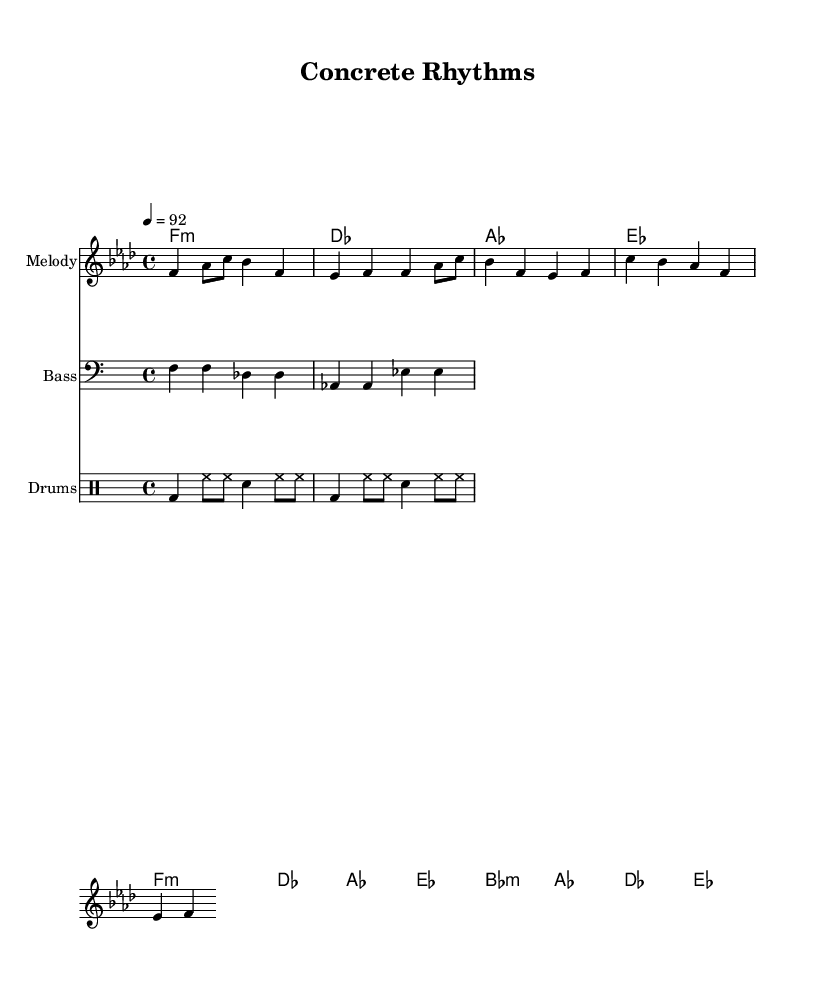What is the key signature of this music? The key signature is indicated by the number of flats or sharps at the beginning of the staff. Here, the music is in F minor, which has four flats (B, E, A, and D).
Answer: F minor What is the time signature of the music sheet? The time signature is displayed as a fraction at the beginning of the staff. In this case, it shows 4/4, indicating four beats per measure and a quarter note receives one beat.
Answer: 4/4 What is the tempo marking for this piece? The tempo is noted at the beginning with a specific numeric value. This piece is marked at 92 beats per minute, indicating how fast it should be played.
Answer: 92 How many measures are in the melody section? By counting the vertical lines (bar lines) in the melody part, we can determine the number of measures. There are eight measures in total in the melody section.
Answer: Eight What is the first chord in the harmony section? The first chord is indicated at the beginning of the harmony line and is notated with the chord name. The first chord here is F minor, denoted as "f1:m".
Answer: F minor Which instrument has a bass clef in the score? The instrument that has a bass clef is indicated within the staff setup. The bass part is notated below the melody and uses a bass clef to show lower pitches.
Answer: Bass Describe the overall rhythmic feel of the drum pattern used. The drum pattern is in a standard hip-hop style, consisting of a kick drum (bd), hi-hats (hh), and snare drum (sn). It employs a repetitive and syncopated rhythm typical for urban beats in rap.
Answer: Syncopated 